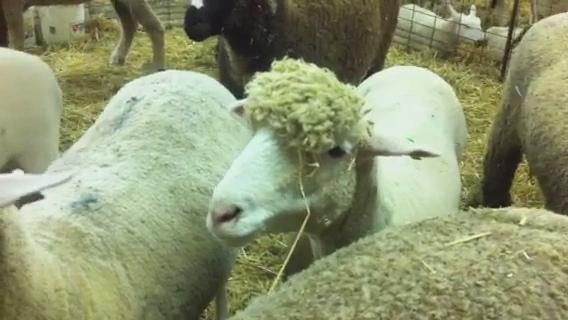What does the fur resemble?

Choices:
A) glasses
B) toque
C) hat
D) mug hat 